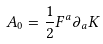Convert formula to latex. <formula><loc_0><loc_0><loc_500><loc_500>A _ { 0 } = \frac { 1 } { 2 } F ^ { a } \partial _ { a } K</formula> 